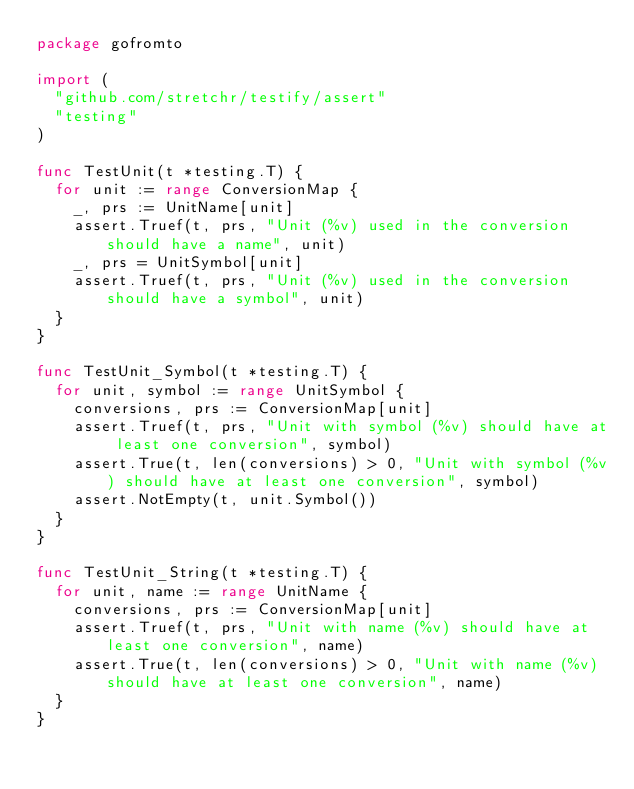<code> <loc_0><loc_0><loc_500><loc_500><_Go_>package gofromto

import (
	"github.com/stretchr/testify/assert"
	"testing"
)

func TestUnit(t *testing.T) {
	for unit := range ConversionMap {
		_, prs := UnitName[unit]
		assert.Truef(t, prs, "Unit (%v) used in the conversion should have a name", unit)
		_, prs = UnitSymbol[unit]
		assert.Truef(t, prs, "Unit (%v) used in the conversion should have a symbol", unit)
	}
}

func TestUnit_Symbol(t *testing.T) {
	for unit, symbol := range UnitSymbol {
		conversions, prs := ConversionMap[unit]
		assert.Truef(t, prs, "Unit with symbol (%v) should have at least one conversion", symbol)
		assert.True(t, len(conversions) > 0, "Unit with symbol (%v) should have at least one conversion", symbol)
		assert.NotEmpty(t, unit.Symbol())
	}
}

func TestUnit_String(t *testing.T) {
	for unit, name := range UnitName {
		conversions, prs := ConversionMap[unit]
		assert.Truef(t, prs, "Unit with name (%v) should have at least one conversion", name)
		assert.True(t, len(conversions) > 0, "Unit with name (%v) should have at least one conversion", name)
	}
}
</code> 